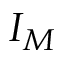<formula> <loc_0><loc_0><loc_500><loc_500>I _ { M }</formula> 